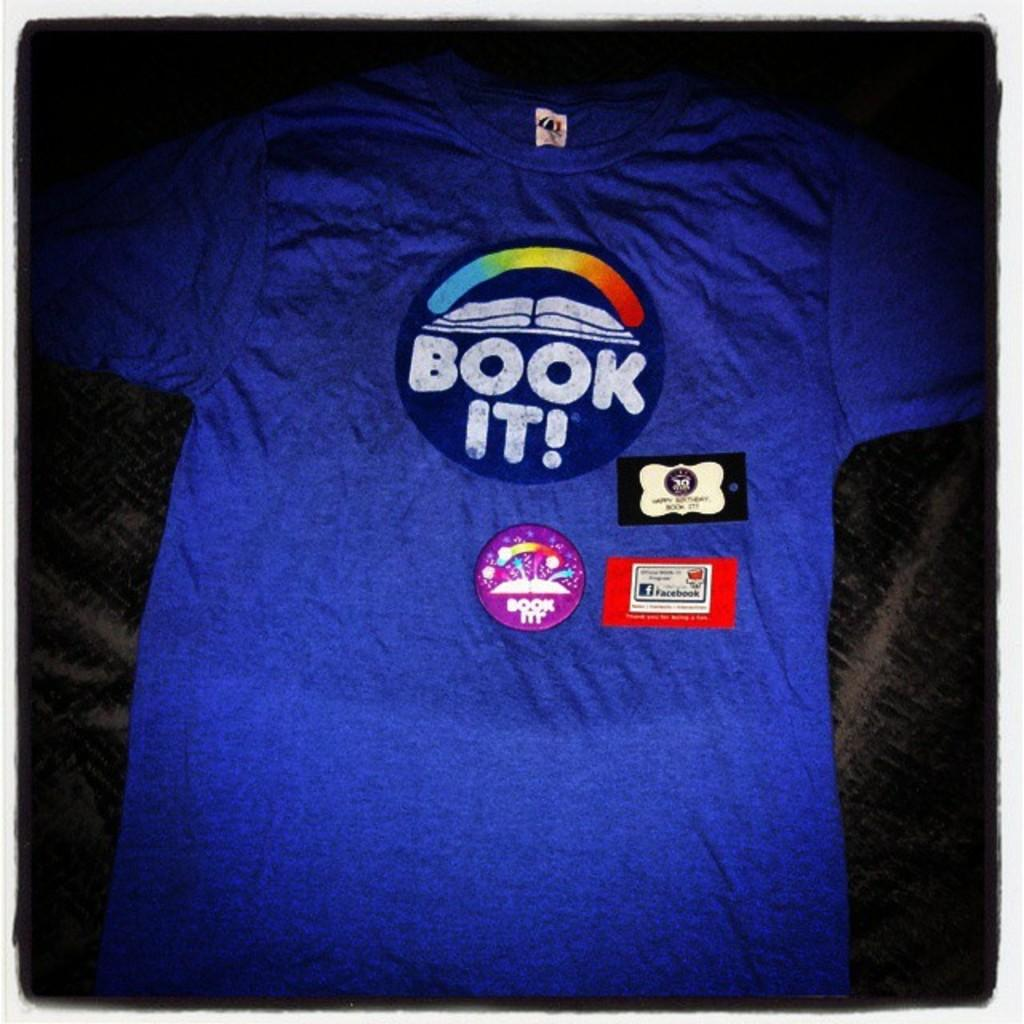<image>
Describe the image concisely. A blue tee shirt has book it written on it. 